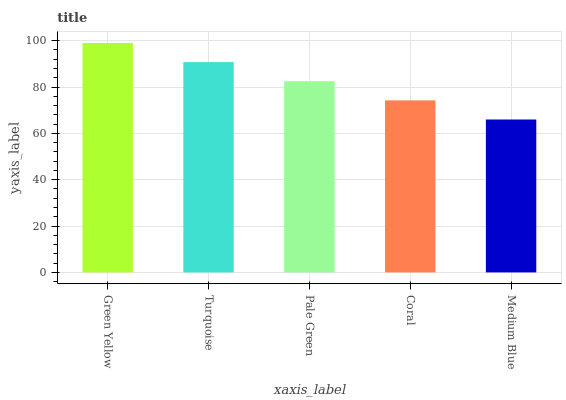Is Turquoise the minimum?
Answer yes or no. No. Is Turquoise the maximum?
Answer yes or no. No. Is Green Yellow greater than Turquoise?
Answer yes or no. Yes. Is Turquoise less than Green Yellow?
Answer yes or no. Yes. Is Turquoise greater than Green Yellow?
Answer yes or no. No. Is Green Yellow less than Turquoise?
Answer yes or no. No. Is Pale Green the high median?
Answer yes or no. Yes. Is Pale Green the low median?
Answer yes or no. Yes. Is Turquoise the high median?
Answer yes or no. No. Is Green Yellow the low median?
Answer yes or no. No. 